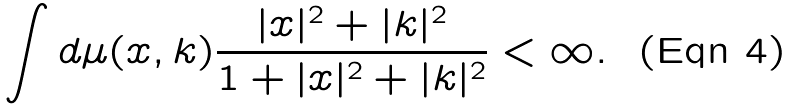Convert formula to latex. <formula><loc_0><loc_0><loc_500><loc_500>\int d \mu ( x , k ) \frac { | x | ^ { 2 } + | k | ^ { 2 } } { 1 + | x | ^ { 2 } + | k | ^ { 2 } } < \infty .</formula> 